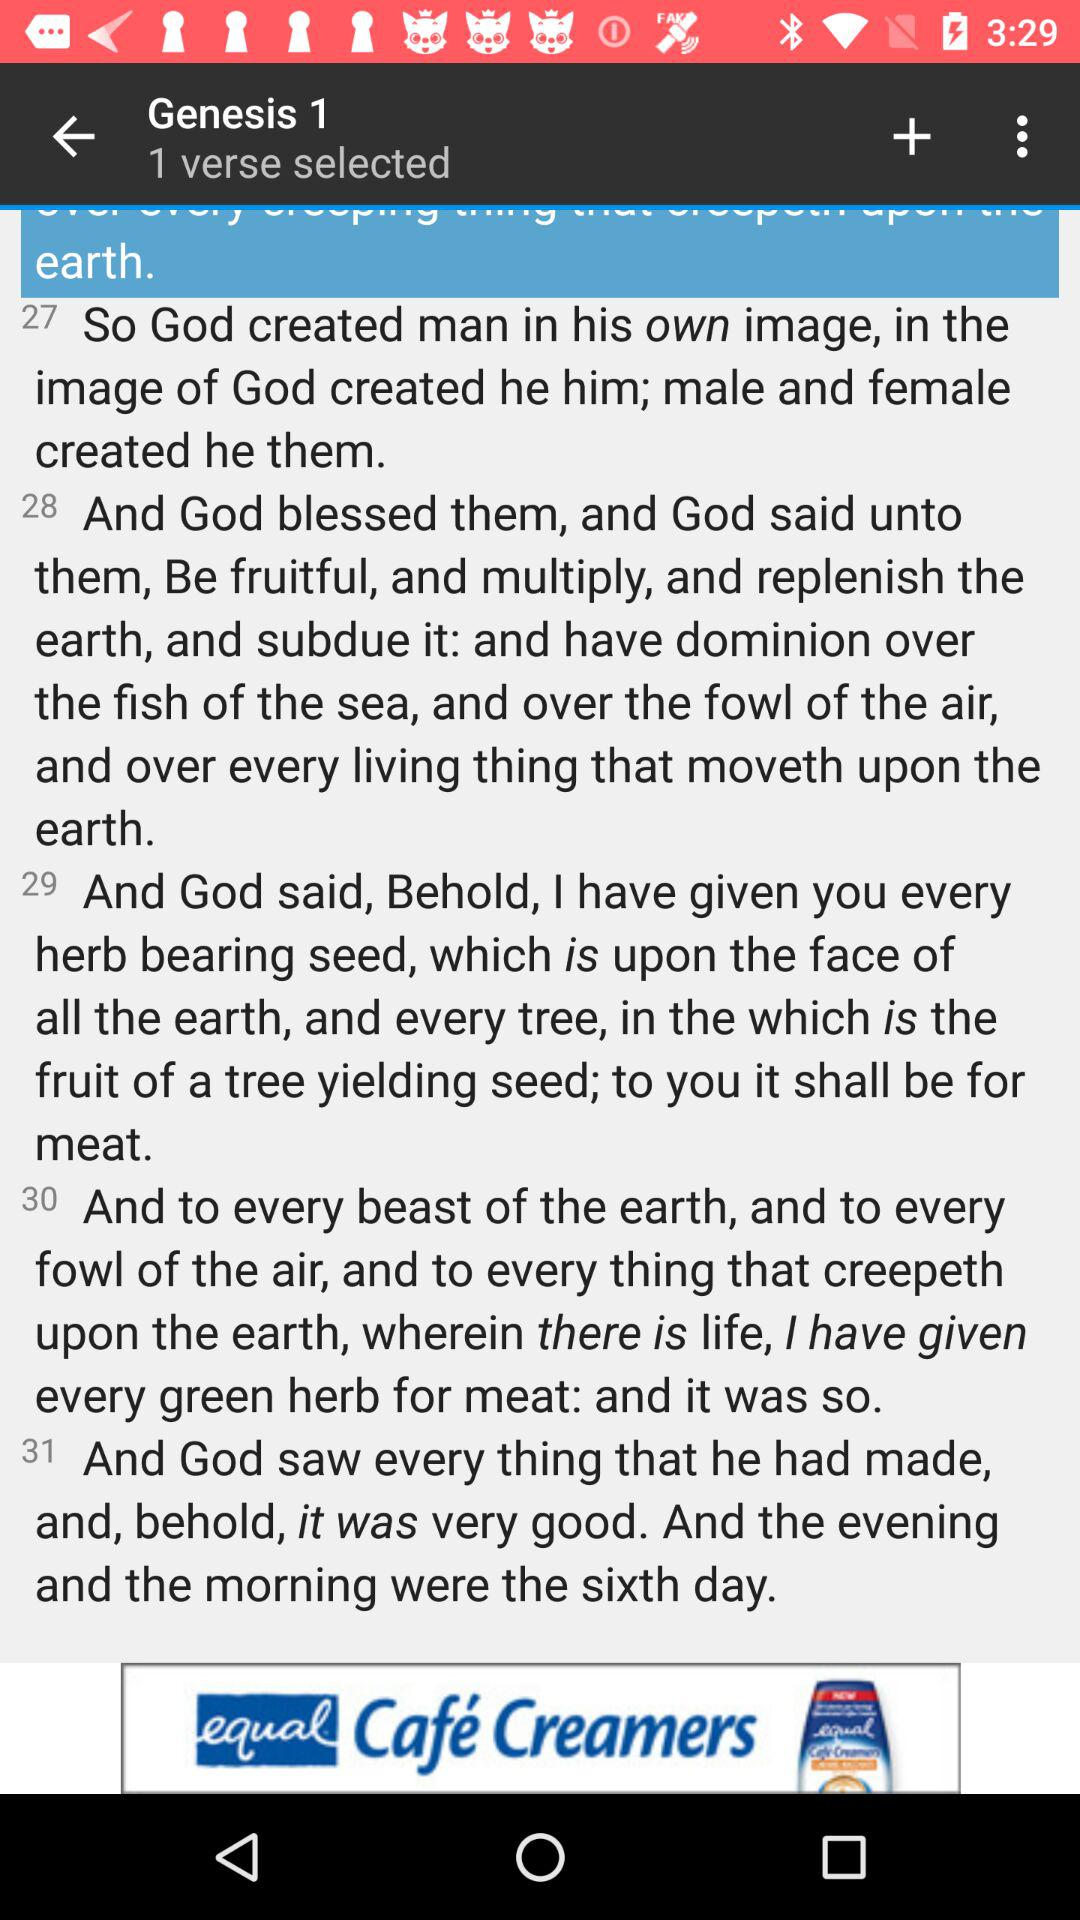How many verses are selected? There is 1 verse selected. 